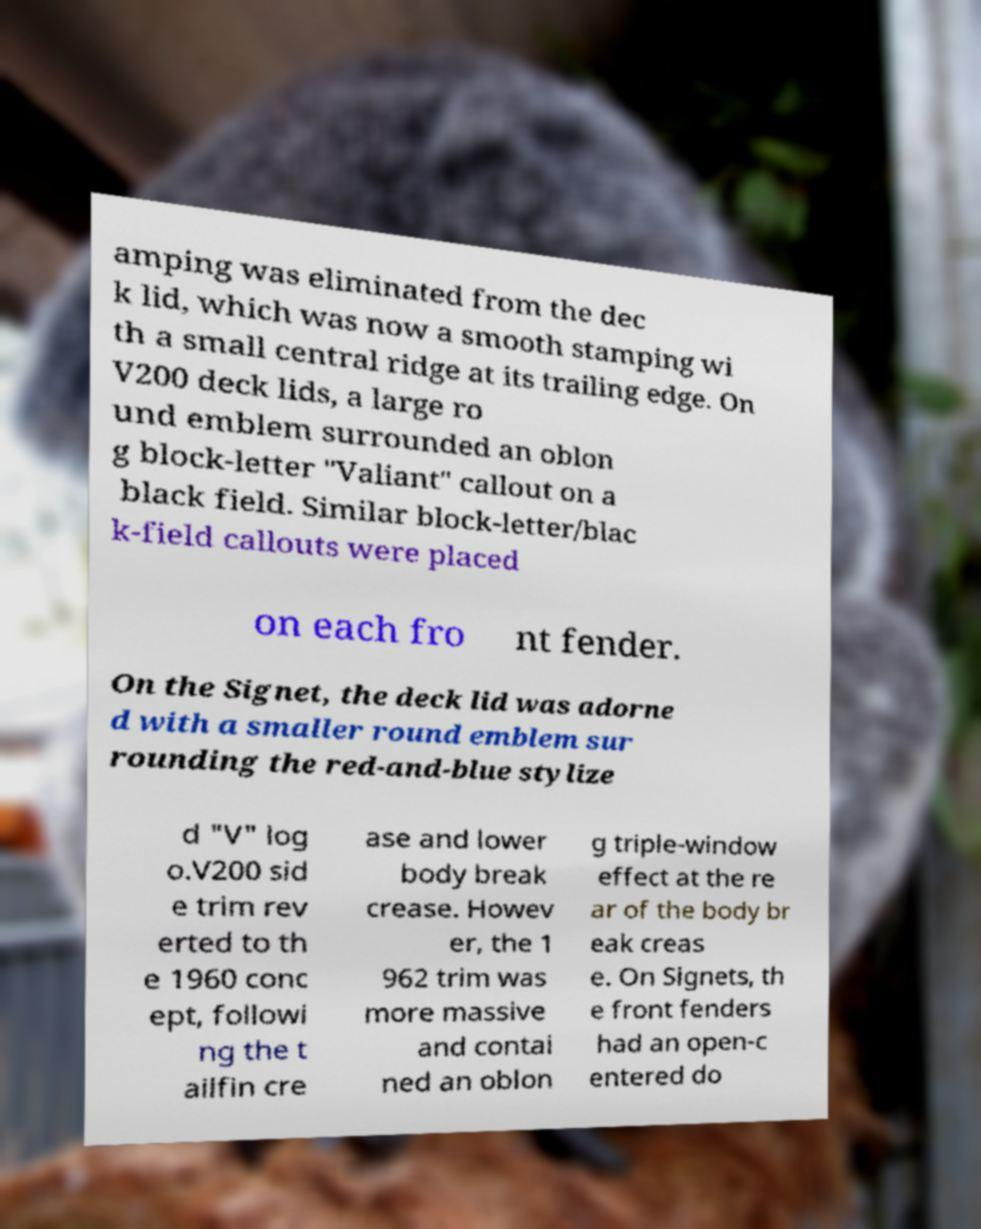Please read and relay the text visible in this image. What does it say? amping was eliminated from the dec k lid, which was now a smooth stamping wi th a small central ridge at its trailing edge. On V200 deck lids, a large ro und emblem surrounded an oblon g block-letter "Valiant" callout on a black field. Similar block-letter/blac k-field callouts were placed on each fro nt fender. On the Signet, the deck lid was adorne d with a smaller round emblem sur rounding the red-and-blue stylize d "V" log o.V200 sid e trim rev erted to th e 1960 conc ept, followi ng the t ailfin cre ase and lower body break crease. Howev er, the 1 962 trim was more massive and contai ned an oblon g triple-window effect at the re ar of the body br eak creas e. On Signets, th e front fenders had an open-c entered do 